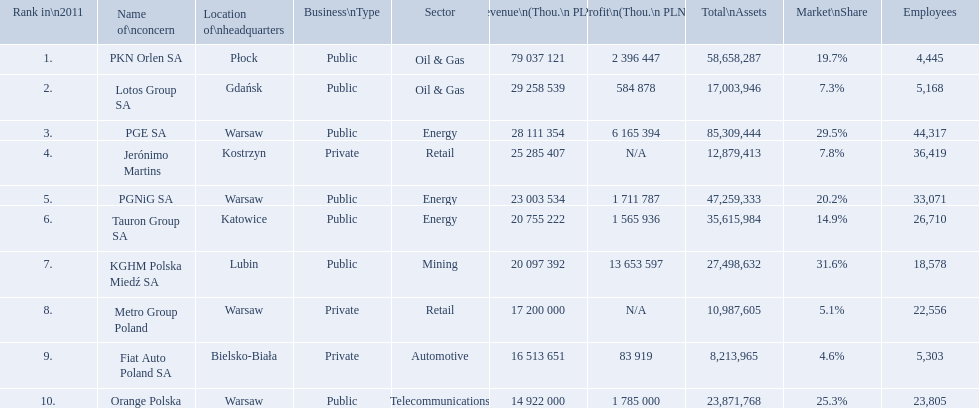What company has 28 111 354 thou.in revenue? PGE SA. What revenue does lotus group sa have? 29 258 539. Who has the next highest revenue than lotus group sa? PKN Orlen SA. What is the number of employees that work for pkn orlen sa in poland? 4,445. What number of employees work for lotos group sa? 5,168. How many people work for pgnig sa? 33,071. What are the names of all the concerns? PKN Orlen SA, Lotos Group SA, PGE SA, Jerónimo Martins, PGNiG SA, Tauron Group SA, KGHM Polska Miedź SA, Metro Group Poland, Fiat Auto Poland SA, Orange Polska. How many employees does pgnig sa have? 33,071. 